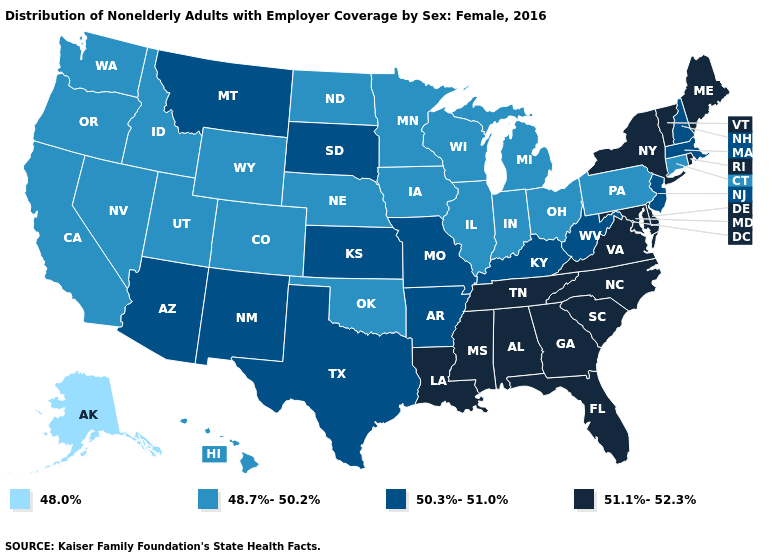What is the value of Montana?
Write a very short answer. 50.3%-51.0%. What is the value of Connecticut?
Answer briefly. 48.7%-50.2%. Name the states that have a value in the range 48.0%?
Answer briefly. Alaska. Does Rhode Island have the same value as Georgia?
Concise answer only. Yes. What is the highest value in the Northeast ?
Answer briefly. 51.1%-52.3%. Name the states that have a value in the range 48.7%-50.2%?
Keep it brief. California, Colorado, Connecticut, Hawaii, Idaho, Illinois, Indiana, Iowa, Michigan, Minnesota, Nebraska, Nevada, North Dakota, Ohio, Oklahoma, Oregon, Pennsylvania, Utah, Washington, Wisconsin, Wyoming. What is the value of Kansas?
Be succinct. 50.3%-51.0%. What is the lowest value in the Northeast?
Write a very short answer. 48.7%-50.2%. Does Maryland have a higher value than Washington?
Give a very brief answer. Yes. Among the states that border Louisiana , which have the highest value?
Write a very short answer. Mississippi. Name the states that have a value in the range 51.1%-52.3%?
Write a very short answer. Alabama, Delaware, Florida, Georgia, Louisiana, Maine, Maryland, Mississippi, New York, North Carolina, Rhode Island, South Carolina, Tennessee, Vermont, Virginia. Name the states that have a value in the range 48.0%?
Keep it brief. Alaska. Among the states that border Illinois , which have the lowest value?
Quick response, please. Indiana, Iowa, Wisconsin. Name the states that have a value in the range 51.1%-52.3%?
Concise answer only. Alabama, Delaware, Florida, Georgia, Louisiana, Maine, Maryland, Mississippi, New York, North Carolina, Rhode Island, South Carolina, Tennessee, Vermont, Virginia. What is the value of Utah?
Concise answer only. 48.7%-50.2%. 